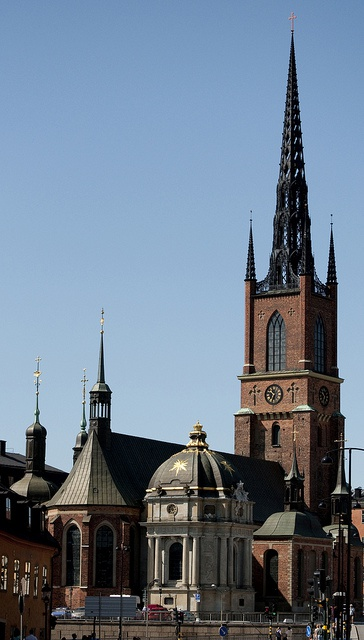Describe the objects in this image and their specific colors. I can see clock in gray, black, and tan tones, clock in black and gray tones, people in gray, black, and maroon tones, people in gray, black, navy, and darkgray tones, and people in gray and black tones in this image. 